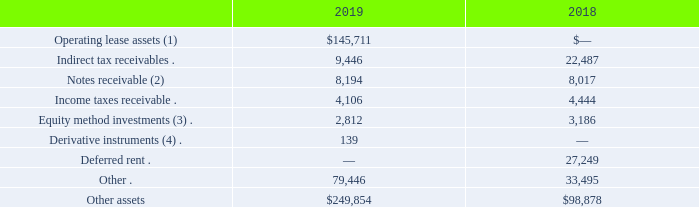Other assets
Other assets consisted of the following at December 31, 2019 and 2018 (in thousands):
(1)    See Note 10. "Leases" to our consolidated financial statements for discussion of our lease arrangements.
(1)    (2)    In April 2009, we entered into a credit facility agreement with a solar power project entity of one of our customers for an available amount of €17.5 million to provide financing for a PV solar power system. The credit facility bears interest at 8.0% per annum, payable quarterly, with the full amount due in December 2026. As of December 31, 2019 and 2018, the balance outstanding on the credit facility was €7.0 million ($7.8 million and $8.0 million, respectively).
(3)    In June 2015, 8point3 Energy Partners LP (the “Partnership”), a limited partnership formed by First Solar and SunPower Corporation (collectively the “Sponsors”), completed its initial public offering (the “IPO”). As part of the IPO, the Sponsors contributed interests in various projects to OpCo in exchange for voting and economic interests in the entity, and the Partnership acquired an economic interest in OpCo using proceeds from the IPO.
In June 2018, we completed the sale of our interests in the Partnership and its subsidiaries to CD Clean Energy and Infrastructure V JV, LLC, an equity fund managed by Capital Dynamics, Inc. and certain other co-investors and other parties, and received net proceeds of $240.0 million after the payment of fees, expenses, and other amounts. We accounted for our interests in OpCo, a subsidiary of the Partnership, under the equity method of accounting as we were able to exercise significant influence over the Partnership due to our representation on the board of directors of its general partner and certain of our associates serving as officers of its general partner. During the year ended December 31, 2018, we recognized equity in earnings, net of tax, of $39.7 million from our investment in OpCo, including a gain of $40.3 million, net of tax, for the sale of our interests in the Partnership and its subsidiaries. During the year ended December 31, 2018, we received distributions from OpCo of $12.4 million.
In connection with the IPO, we also entered into an agreement with a subsidiary of the Partnership to lease back one of our originally contributed projects, Maryland Solar, until December 31, 2019. Under the terms of the agreement, we made fixed rent payments to the Partnership’s subsidiary and were entitled to all of the energy generated by the project. Due to certain continuing involvement with the project, we accounted for the leaseback agreement as a financing transaction until the sale of our interests in the Partnership and its subsidiaries in June 2018. Following the sale of such interests, the Maryland Solar project qualified for sale-leaseback accounting, and we recognized net revenue of $32.0 million from the sale of the project.
(4)    See Note 9. “Derivative Financial Instruments” to our consolidated financial statements for discussion of our derivative instruments.
What is the interest rate on the credit facility agreement? 8.0% per annum. When did 8point3 Energy Partners LP complete its initial IPO? June 2015. How much distribution was received from OpCo in 2018? $12.4 million. What is the change in operating lease assets from 2018 to 2019?
Answer scale should be: thousand. 145,711 - 0 
Answer: 145711. How much did the deferred rent decrease from 2018 to 2019?
Answer scale should be: thousand. 0 - 27,249 
Answer: -27249. What is the percentage change in other assets from 2018 to 2019?
Answer scale should be: percent. (249,854 - 98,878) / 98,878 
Answer: 152.69. 